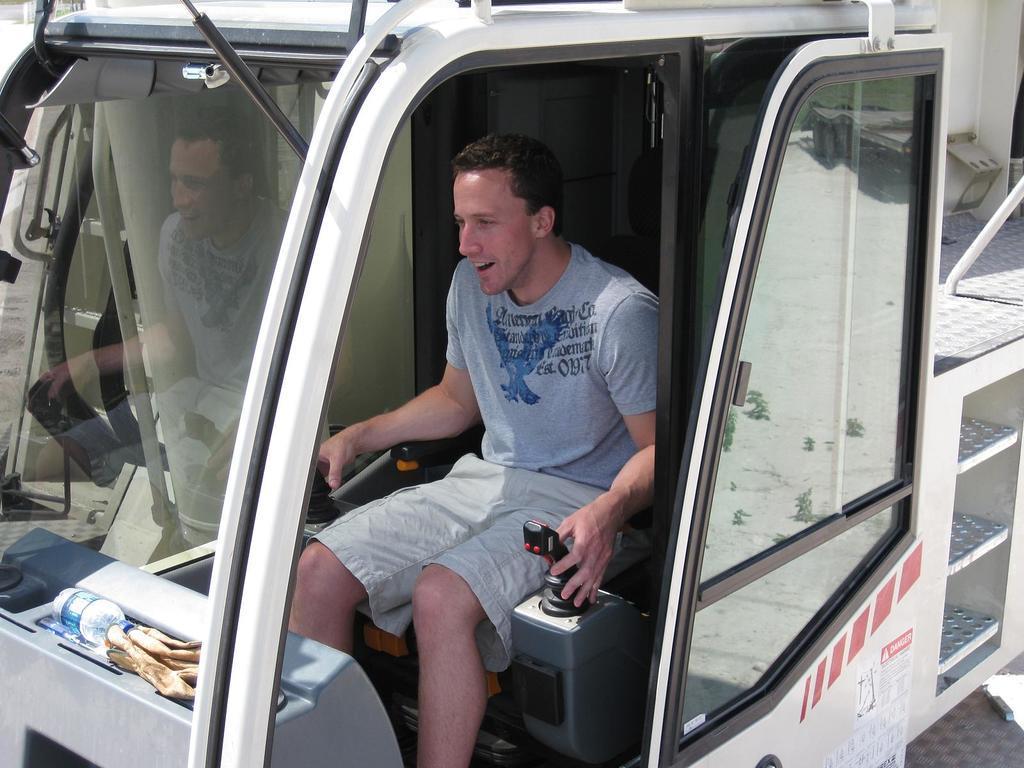Can you describe this image briefly? In the foreground of this picture we can see a person wearing t-shirt and seems to be riding a vehicle. On the left we can see a water bottle and some other objects and we can see the text and a picture of a bird on the t-shirt. In the background we can see a metal rod and some objects. On the left we can see the reflection of a person on the windshield of a vehicle. 